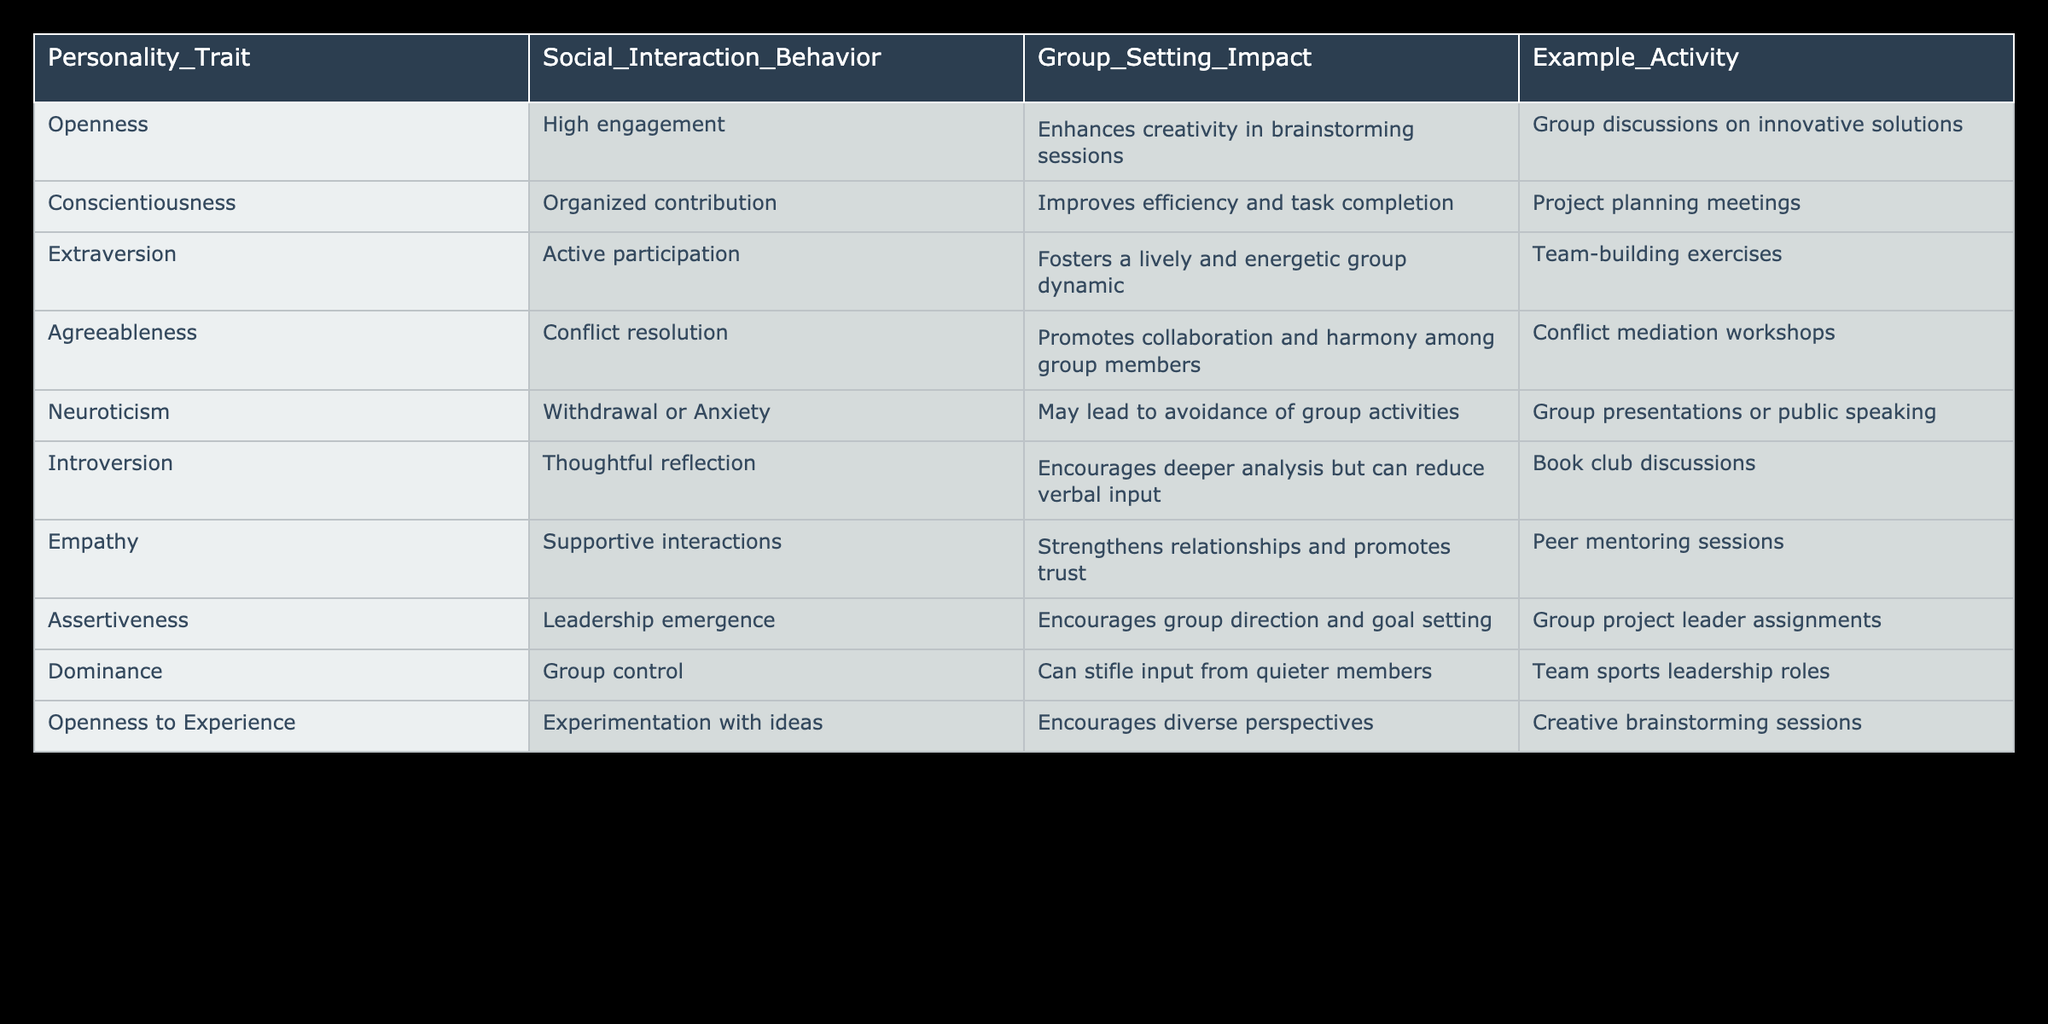What social interaction behavior is associated with Openness? The table indicates that the social interaction behavior associated with Openness is High engagement. This can be directly found by looking at the corresponding row for Openness.
Answer: High engagement In which group setting can Conscientiousness improve efficiency? According to the table, Conscientiousness improves efficiency and task completion in Project planning meetings. This information is present in the relevant row for Conscientiousness.
Answer: Project planning meetings Is Extraversion linked to a positive social interaction behavior? Yes, the table shows that Extraversion is associated with Active participation, which fosters a lively and energetic group dynamic. This confirms the positive link.
Answer: Yes Which personality trait is most likely to encourage deeper analysis in group settings? From the table, Introversion is associated with Thoughtful reflection, which encourages deeper analysis but can reduce verbal input. This is the relevant row to consult for the answer.
Answer: Introversion What is the difference in social interaction behavior between Dominance and Agreeableness? Dominance leads to Group control, which can stifle input from quieter members, while Agreeableness promotes Conflict resolution that fosters collaboration. The difference can be understood as teamwork facilitation versus possibly hindering contributions.
Answer: Dominance stifles input; Agreeableness promotes collaboration What would be the total number of interaction behaviors that enhance creativity? The table lists High engagement and Experimentation with ideas, both of which imply enhancing creativity. Summing these creative-associated behaviors gives a total of 2.
Answer: 2 Does Neuroticism contribute to positive social interaction behaviors? No, the data shows that Neuroticism is linked to Withdrawal or Anxiety, often leading to avoidance of group activities, indicating a negative contribution.
Answer: No In what type of activity does Empathy strengthen relationships? Empathy is linked to Supportive interactions, particularly enhancing relationships in Peer mentoring sessions, as mentioned in the relevant row for Empathy.
Answer: Peer mentoring sessions Which personality trait fosters a lively group dynamic? Extraversion is the personality trait that fosters a lively and energetic group dynamic, as seen in the table. This confirms which trait promotes that behavior.
Answer: Extraversion 